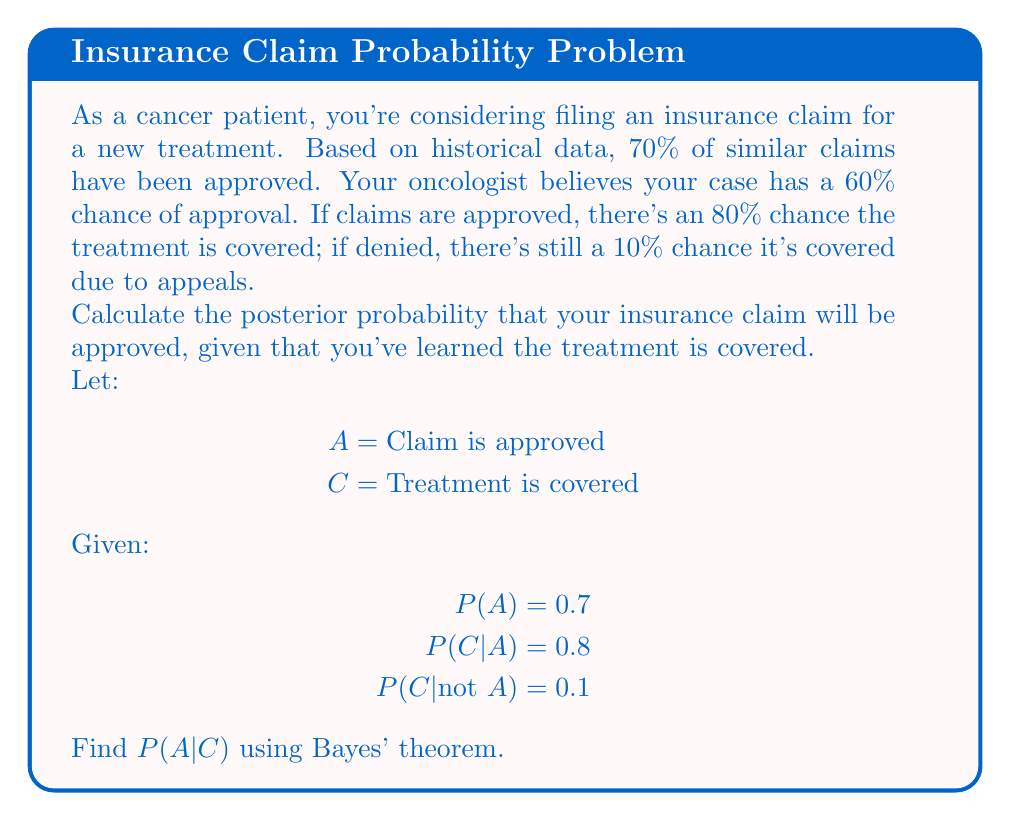What is the answer to this math problem? To solve this problem, we'll use Bayes' theorem:

$$ P(A|C) = \frac{P(C|A) \cdot P(A)}{P(C)} $$

We're given P(A), P(C|A), and P(C|not A). We need to calculate P(C) using the law of total probability:

$$ P(C) = P(C|A) \cdot P(A) + P(C|not A) \cdot P(not A) $$

Step 1: Calculate P(not A)
$$ P(not A) = 1 - P(A) = 1 - 0.7 = 0.3 $$

Step 2: Calculate P(C)
$$ P(C) = 0.8 \cdot 0.7 + 0.1 \cdot 0.3 = 0.56 + 0.03 = 0.59 $$

Step 3: Apply Bayes' theorem
$$ P(A|C) = \frac{0.8 \cdot 0.7}{0.59} = \frac{0.56}{0.59} \approx 0.9492 $$

Therefore, the posterior probability that your insurance claim will be approved, given that the treatment is covered, is approximately 0.9492 or 94.92%.
Answer: 0.9492 